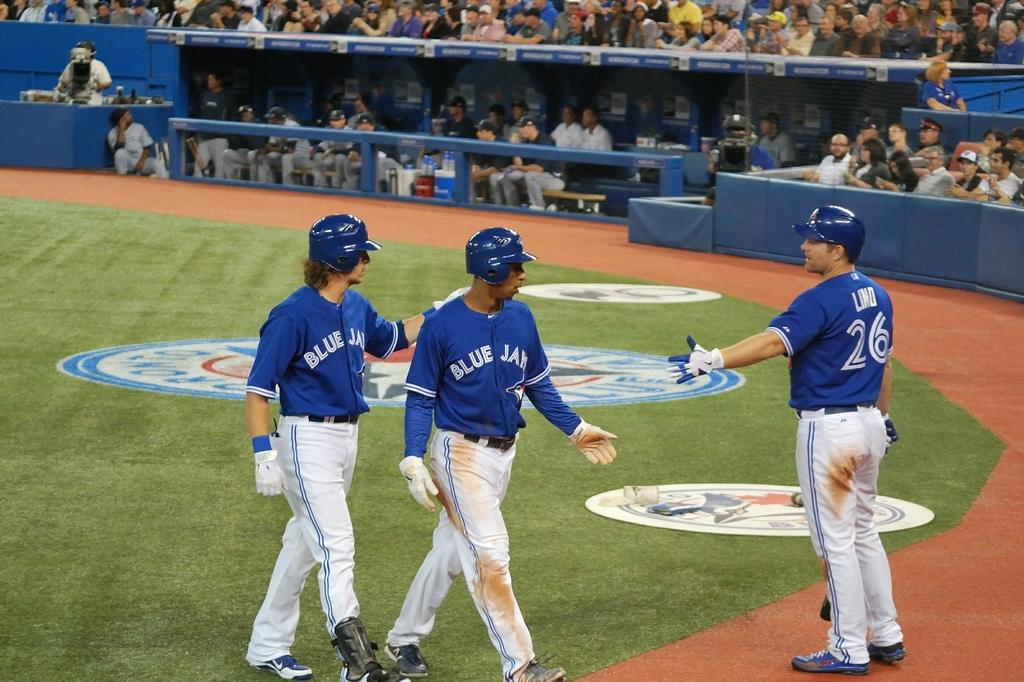Provide a one-sentence caption for the provided image. Two players from the Blue Jays are being offered a hand slap by someone else on their team. 